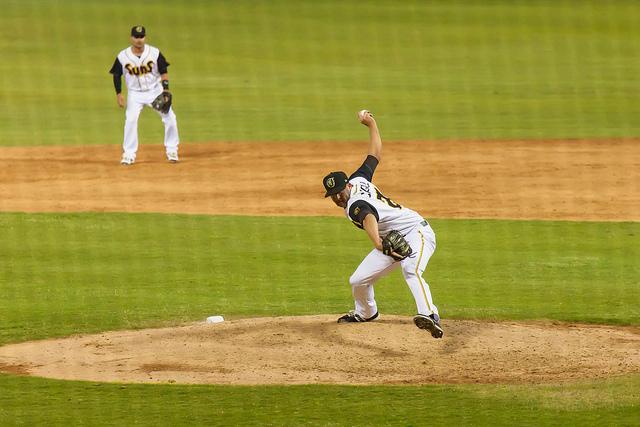What color is the pitcher's mitt?
Keep it brief. Black. Why is the man's arm raised?
Give a very brief answer. Pitching. Do these players look like professionals?
Concise answer only. Yes. 